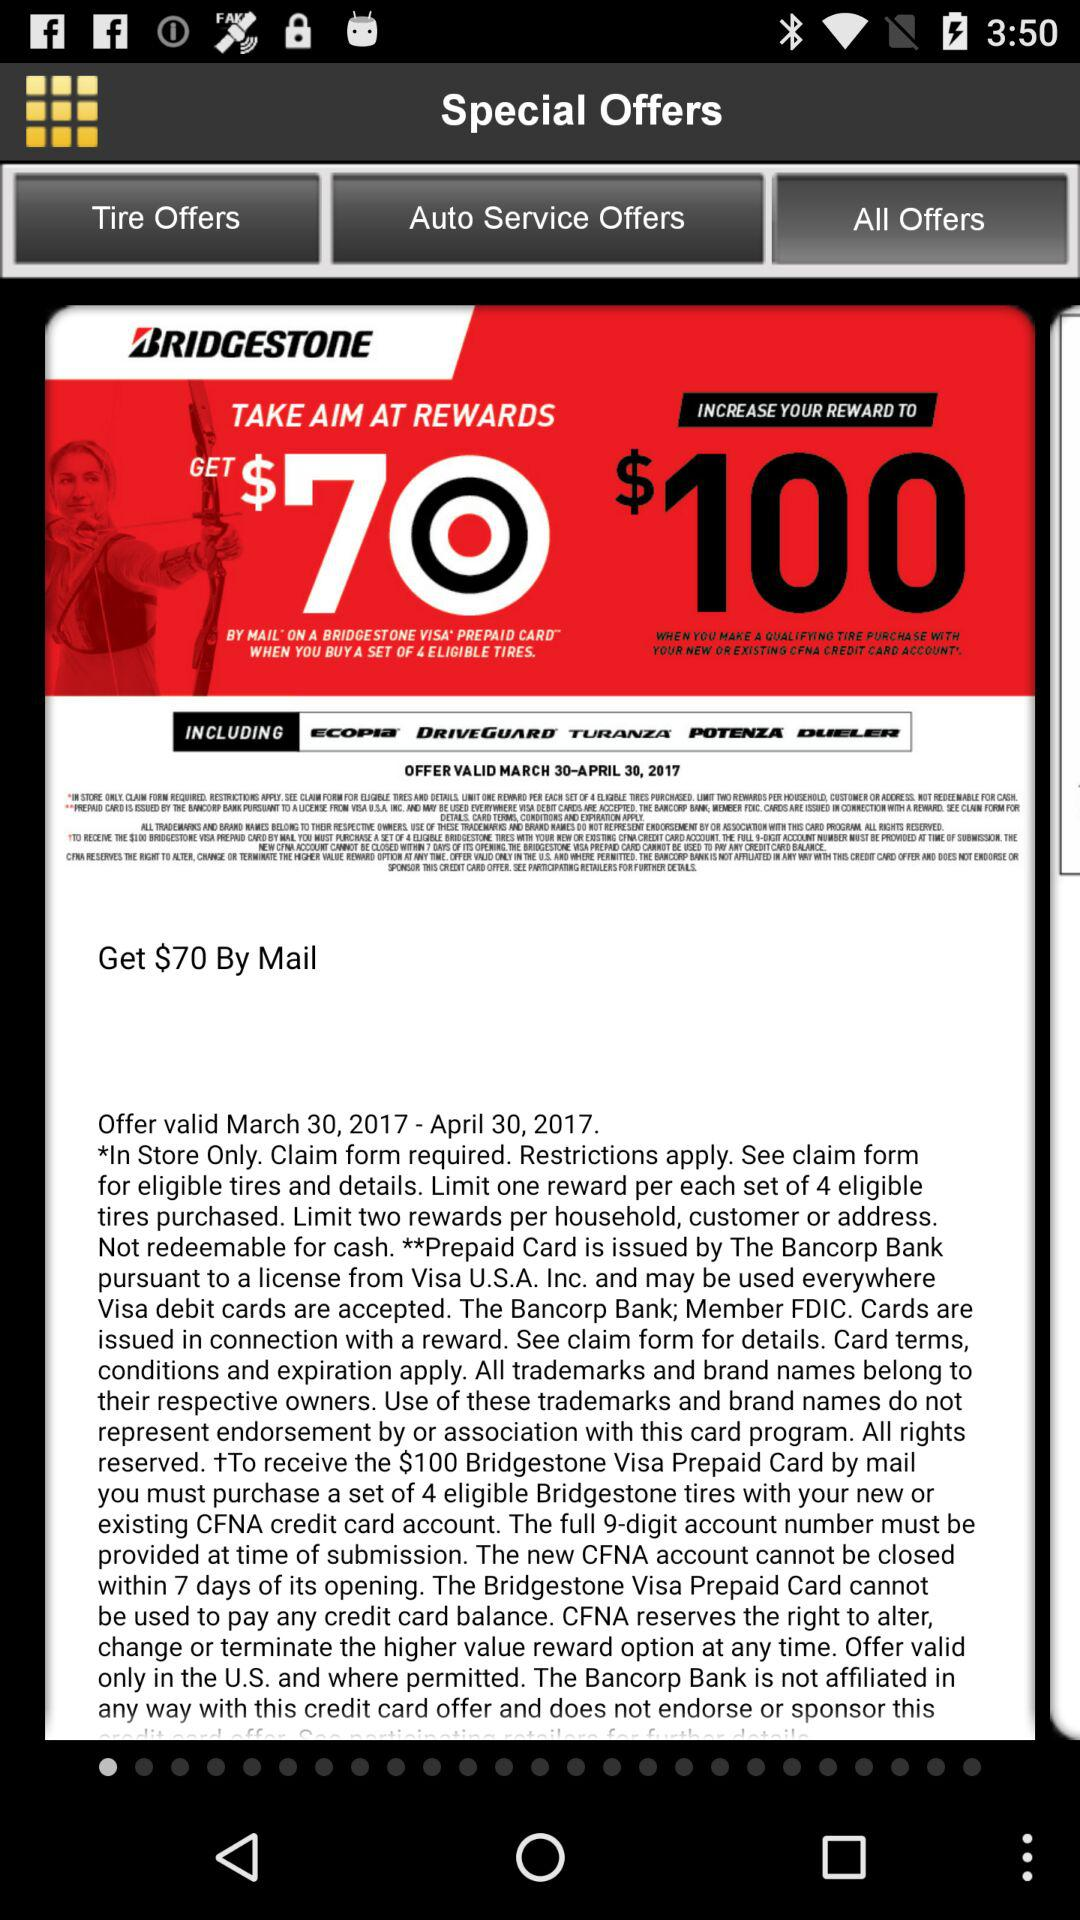What amount will I get by mail? You will get $70 by mail. 